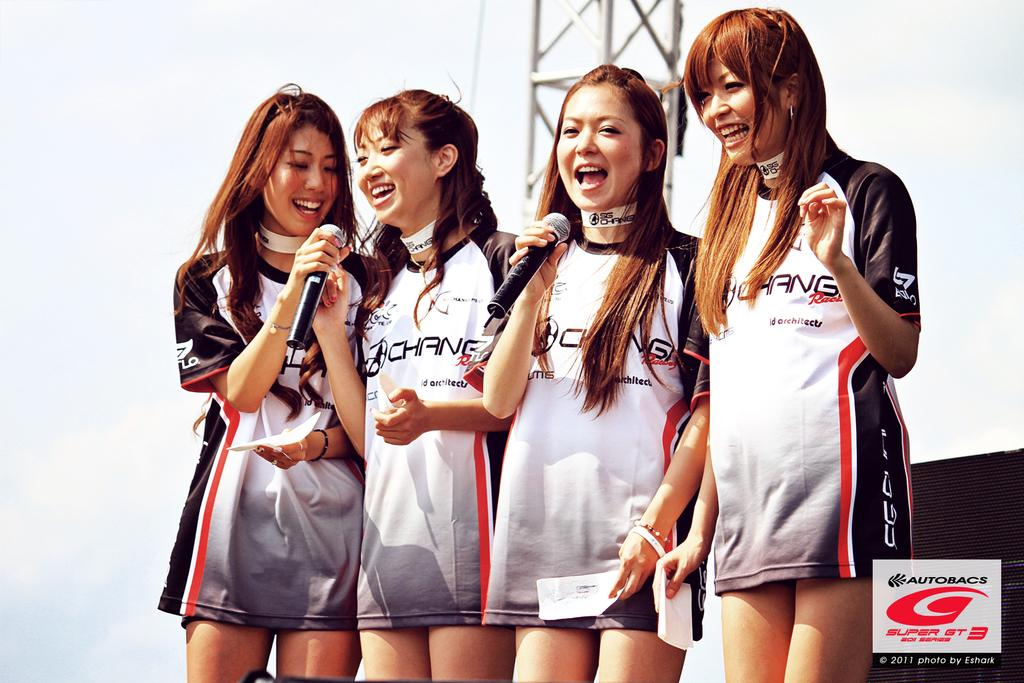<image>
Share a concise interpretation of the image provided. The female models were photographed by Eshark in 2011 